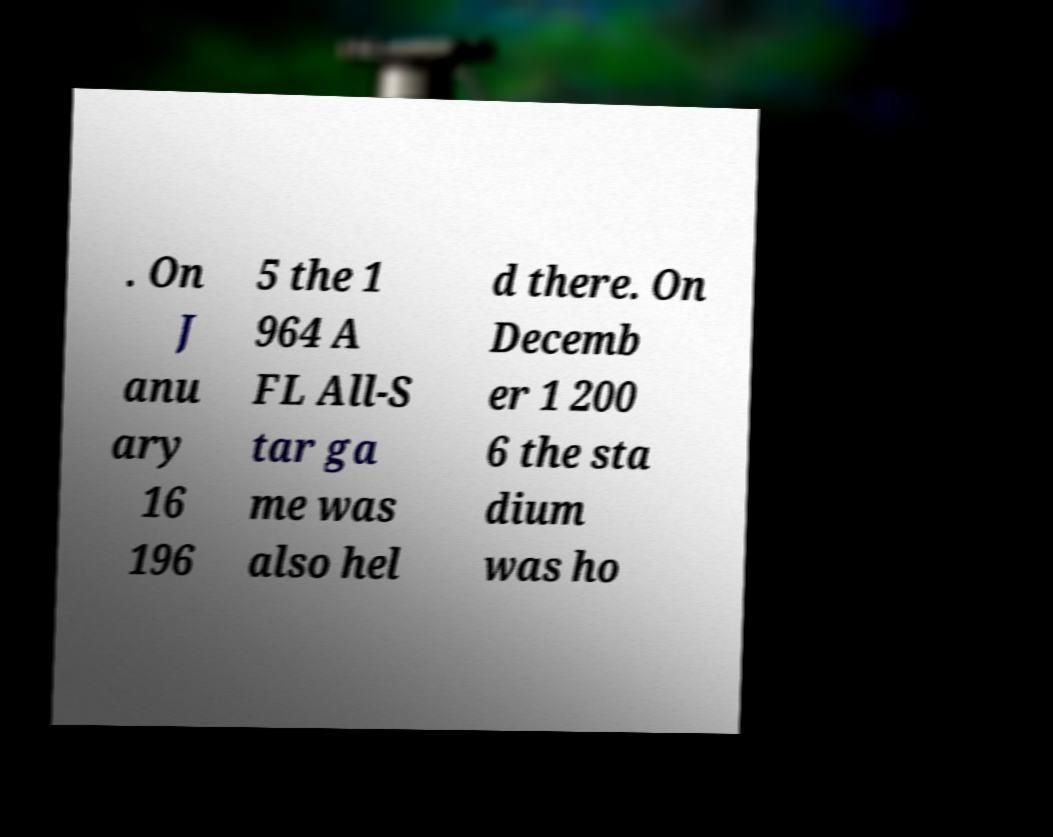What messages or text are displayed in this image? I need them in a readable, typed format. . On J anu ary 16 196 5 the 1 964 A FL All-S tar ga me was also hel d there. On Decemb er 1 200 6 the sta dium was ho 